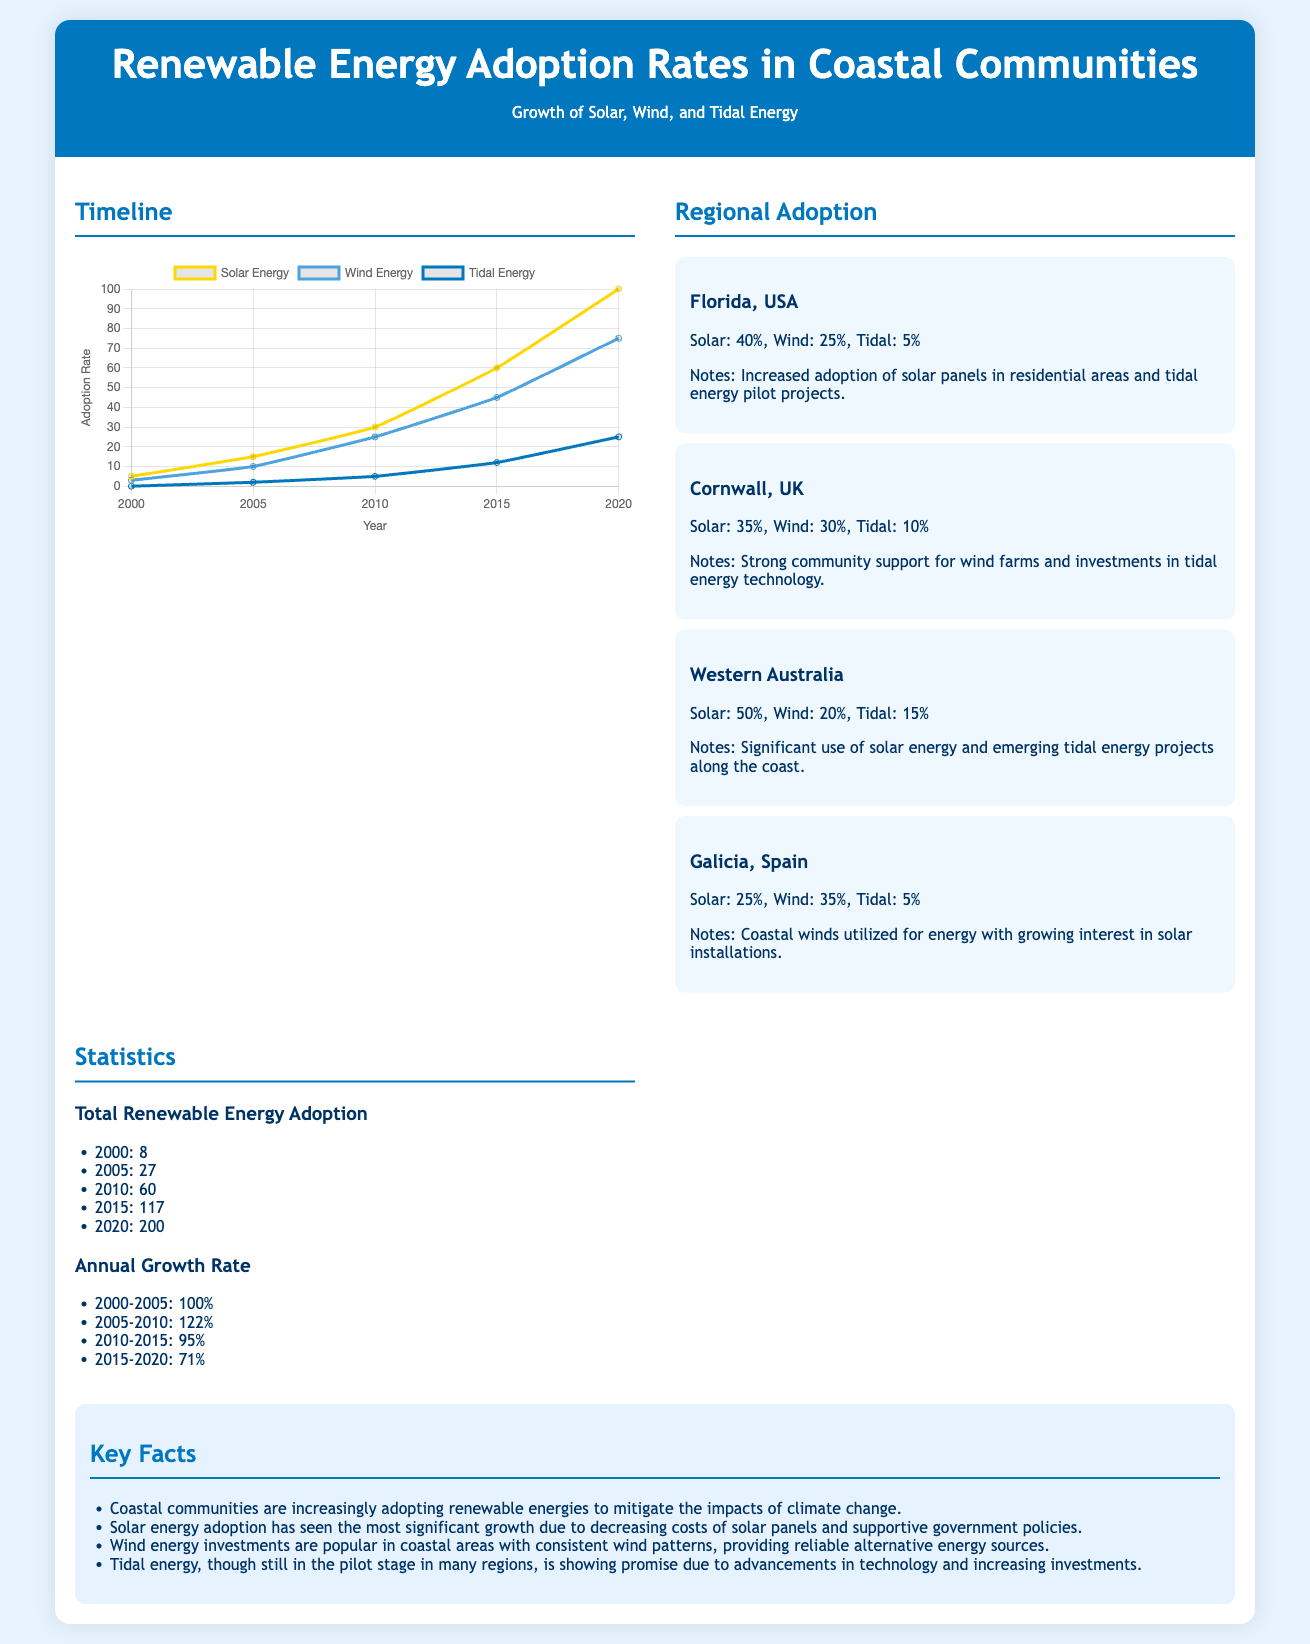what is the solar energy adoption rate in Florida? The document states that Florida has a solar energy adoption rate of 40%.
Answer: 40% what was the total renewable energy adoption in 2010? The total renewable energy adoption in 2010 is listed in the statistics section as 60.
Answer: 60 which coastal community has the highest solar energy adoption rate? Western Australia has the highest solar energy adoption rate, which is 50%.
Answer: 50% what year saw a total adoption of 200 renewable energy sources? The year that saw a total adoption of 200 is 2020.
Answer: 2020 which energy source had the lowest adoption rate in Galicia, Spain? The lowest adoption rate in Galicia, Spain is for tidal energy, which is 5%.
Answer: 5% what is the annual growth rate for the period 2010-2015? The annual growth rate for the period from 2010 to 2015 is 95%.
Answer: 95% what type of infographic is this document classified as? This document is classified as a statistical infographic focusing on energy adoption rates.
Answer: statistical infographic how many wind energy sources were adopted in Western Australia? The document shows that Western Australia adopted 20% wind energy sources.
Answer: 20% what is one key fact mentioned about coastal communities? One key fact is that coastal communities are increasingly adopting renewable energies to mitigate climate change impacts.
Answer: increasing adoption 